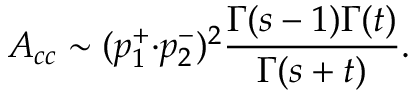<formula> <loc_0><loc_0><loc_500><loc_500>A _ { c c } \sim ( p _ { 1 } ^ { + } { \cdot } p _ { 2 } ^ { - } ) ^ { 2 } \frac { \Gamma ( s - 1 ) \Gamma ( t ) } { \Gamma ( s + t ) } .</formula> 